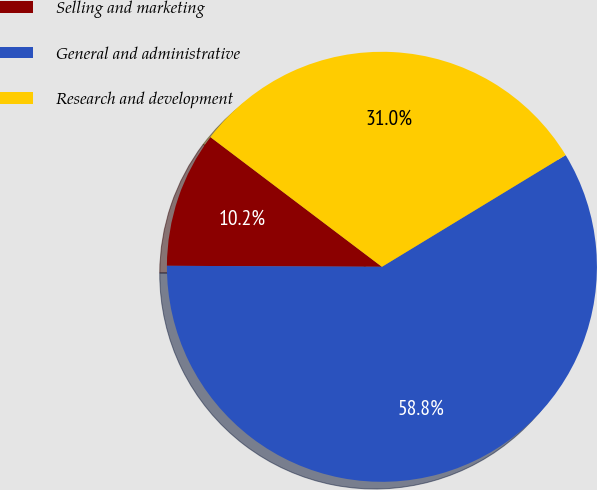Convert chart. <chart><loc_0><loc_0><loc_500><loc_500><pie_chart><fcel>Selling and marketing<fcel>General and administrative<fcel>Research and development<nl><fcel>10.23%<fcel>58.77%<fcel>31.0%<nl></chart> 